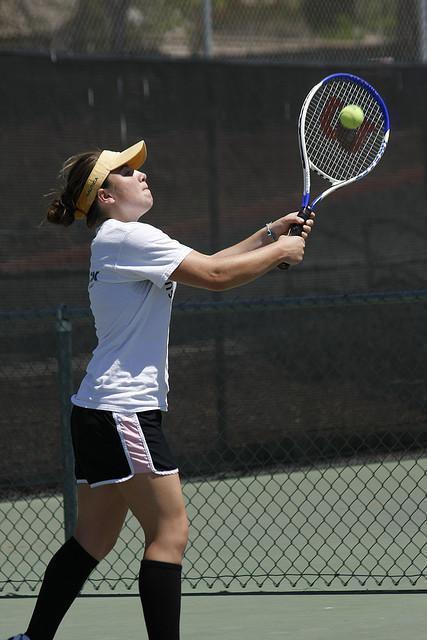What is the most common tennis racquet string material?
Make your selection from the four choices given to correctly answer the question.
Options: Cotton, nylon, steel, animal guts. Animal guts. 